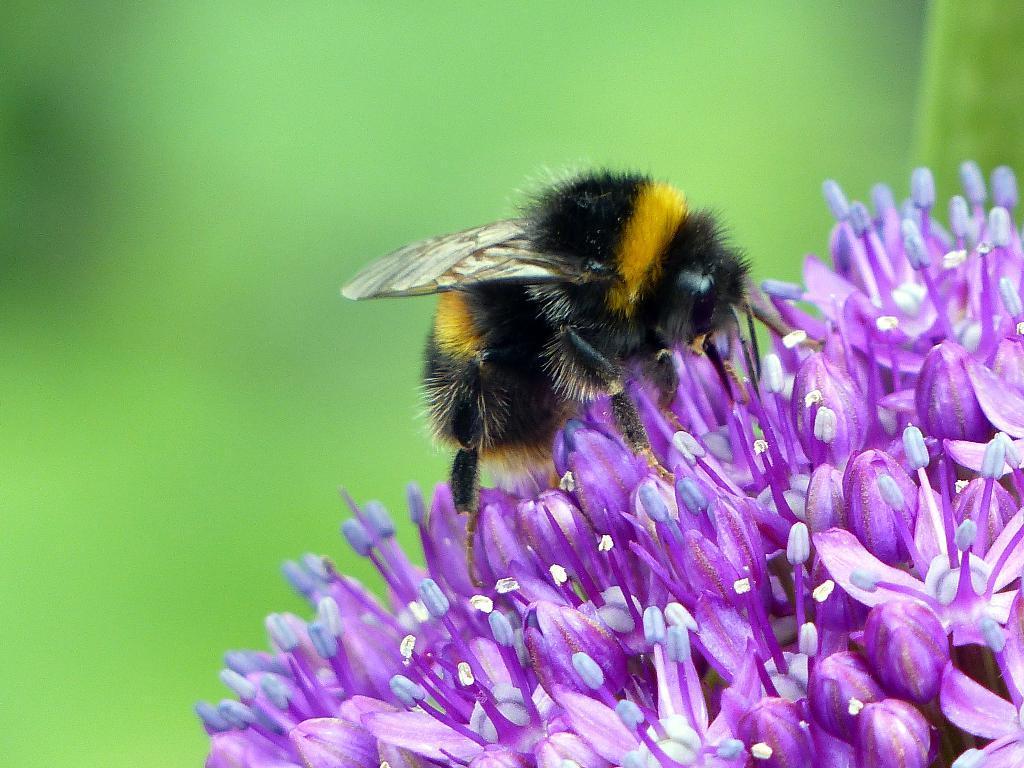Describe this image in one or two sentences. In this image there are flowers. There is a honey bee on the flowers. The background is blurry. 